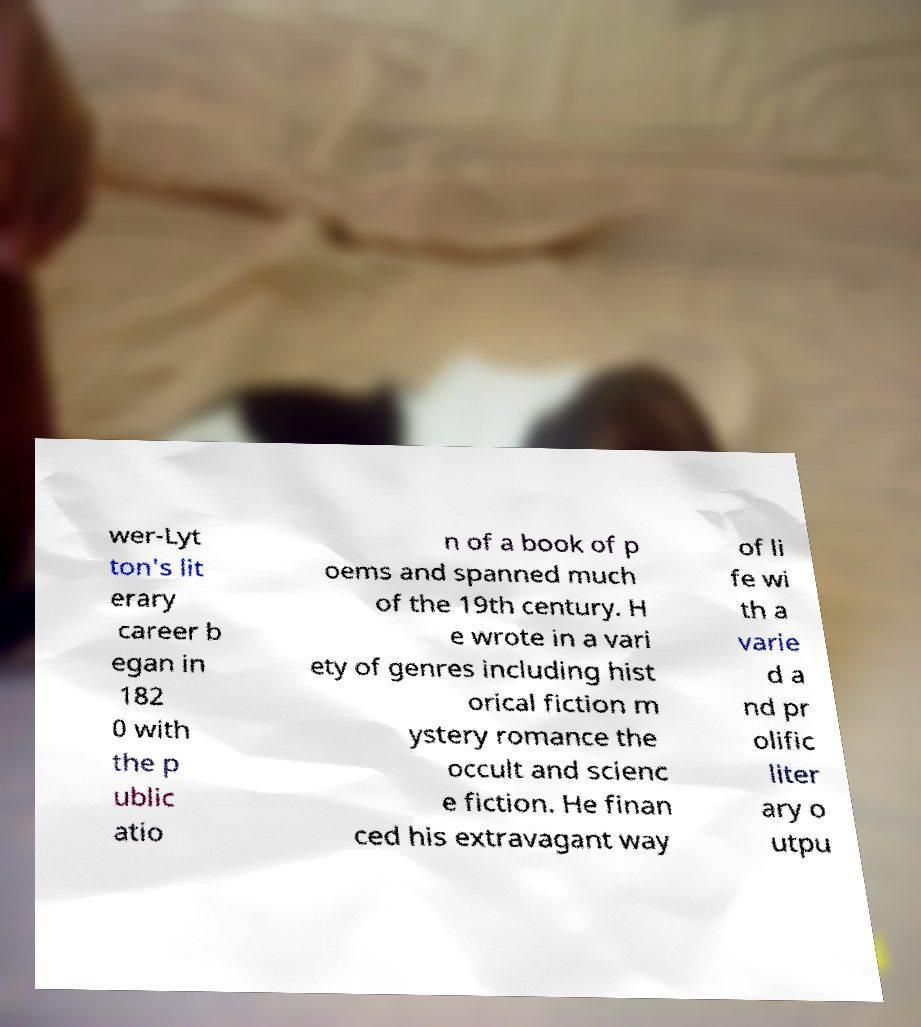Please identify and transcribe the text found in this image. wer-Lyt ton's lit erary career b egan in 182 0 with the p ublic atio n of a book of p oems and spanned much of the 19th century. H e wrote in a vari ety of genres including hist orical fiction m ystery romance the occult and scienc e fiction. He finan ced his extravagant way of li fe wi th a varie d a nd pr olific liter ary o utpu 